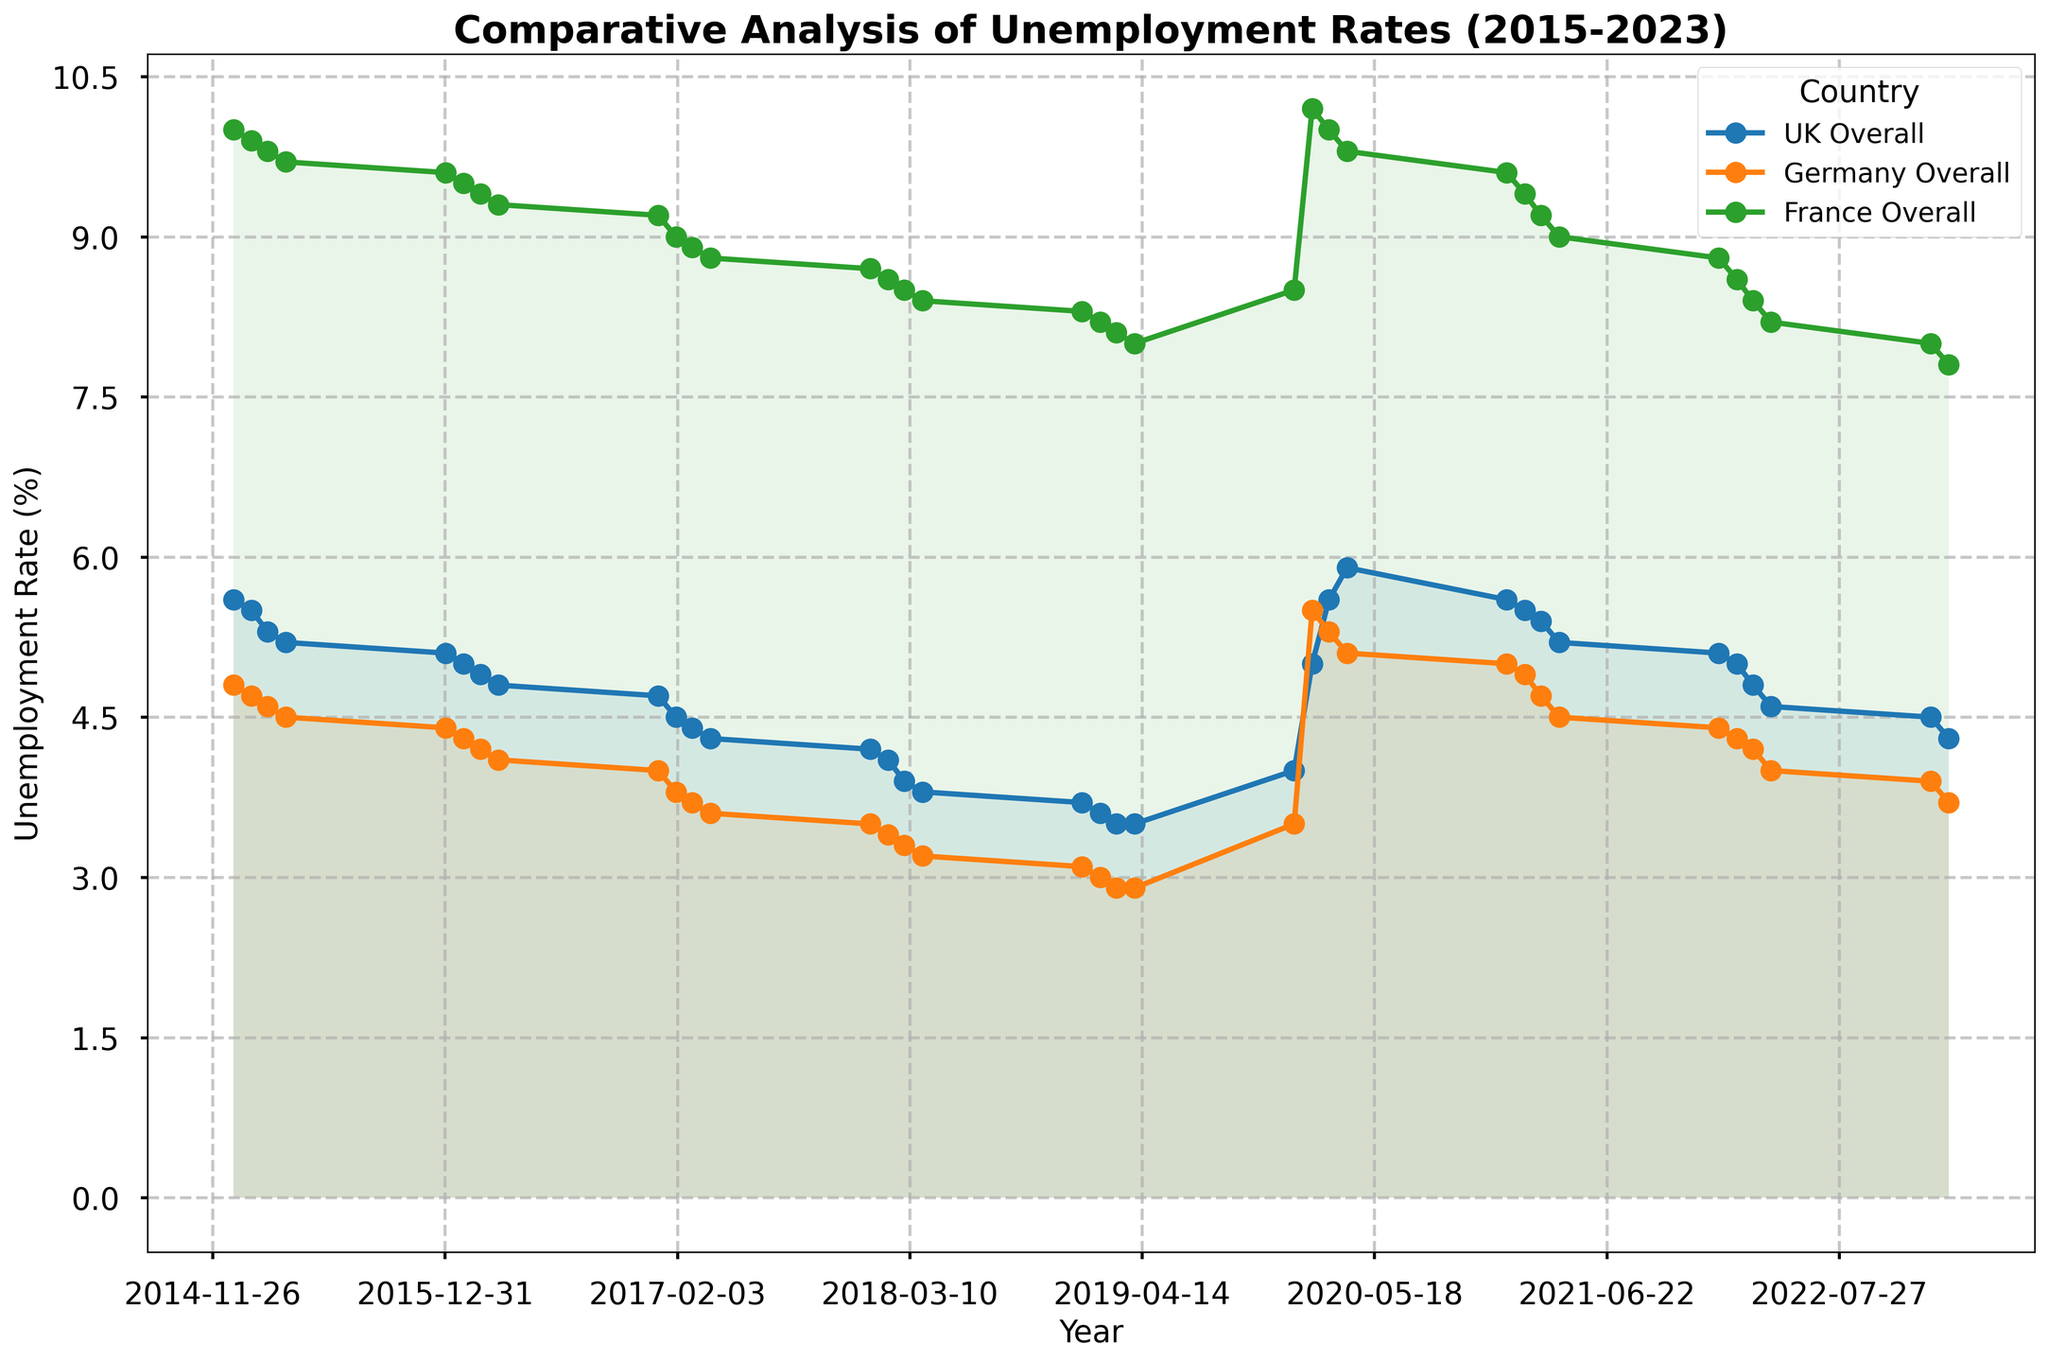What's the overall trend in unemployment rates for the UK, Germany, and France from 2015 to 2023? By examining the plot, we can observe that all three countries generally have a downward trend in unemployment rates over the period from 2015 to 2019. However, there is a noticeable spike in 2020 during the pandemic, followed by a gradual decline again.
Answer: Downward trend with a spike in 2020 Which country had the highest unemployment rate peak in 2020? By comparing the peaks in 2020 for the UK, Germany, and France on the plot, we can see that France had the highest unemployment rate peak among the three countries.
Answer: France How did the UK's unemployment rate in Q2 2020 compare to Q2 2021? By looking at the filled area for the UK in Q2 2020 and Q2 2021, we can see that the unemployment rate in Q2 2020 was higher than in Q2 2021.
Answer: Higher in Q2 2020 Between 2015 and 2023, which country showed the most significant overall reduction in unemployment rate? By observing the start and end points for each country, Germany shows the largest reduction from around 4.8% in 2015 to about 3.7% in 2023.
Answer: Germany What differences can be seen between the UK and Germany's unemployment trajectory during the COVID-19 pandemic (2020-2023)? By checking both countries' trends from 2020 to 2023, both show a peak in 2020 followed by a decline. However, Germany's rate decreases more steadily compared to the UK.
Answer: Germany shows a more steady decline In which quarter did the UK reach its highest unemployment rate from 2015 to 2023? By identifying the highest point on the UK's unemployment rate trend, it is evident that Q4 2020 is the peak period.
Answer: Q4 2020 Visualize the gap between the highest and lowest unemployment rates for France and describe any observed patterns. By comparing the peaks and troughs in France's trendline, the largest gap is seen between Q2 2020 and around Q1 2023, representing a decrease after a pandemic spike.
Answer: Largest in Q2 2020, reducing by Q1 2023 Which sector consistently exhibited the highest unemployment rates across the three countries? By focusing on filled areas representing different sectors, the "Construction" sector tends to have higher unemployment rates compared to others.
Answer: Construction 